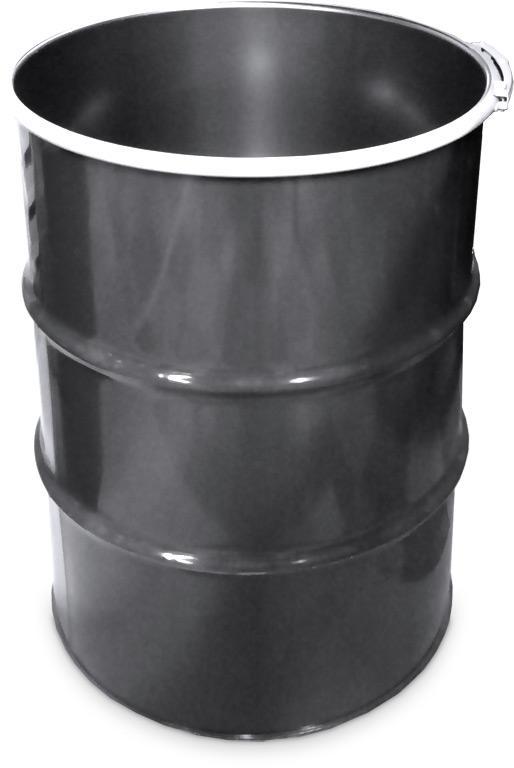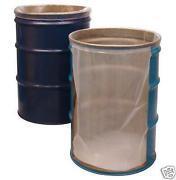The first image is the image on the left, the second image is the image on the right. Given the left and right images, does the statement "There are at least four cans." hold true? Answer yes or no. No. The first image is the image on the left, the second image is the image on the right. Considering the images on both sides, is "All barrels shown are the same color, but one image contains a single barrel, while the other contains at least five." valid? Answer yes or no. No. 